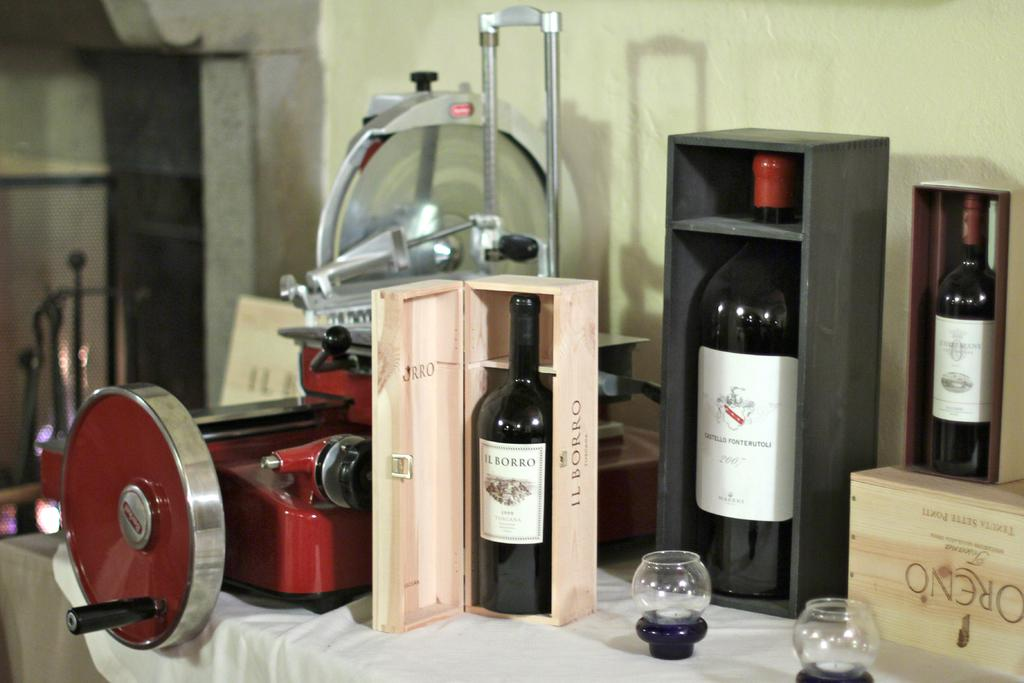Provide a one-sentence caption for the provided image. table with a red machine and 3 boxes of wine including il borro. 